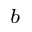Convert formula to latex. <formula><loc_0><loc_0><loc_500><loc_500>^ { b }</formula> 